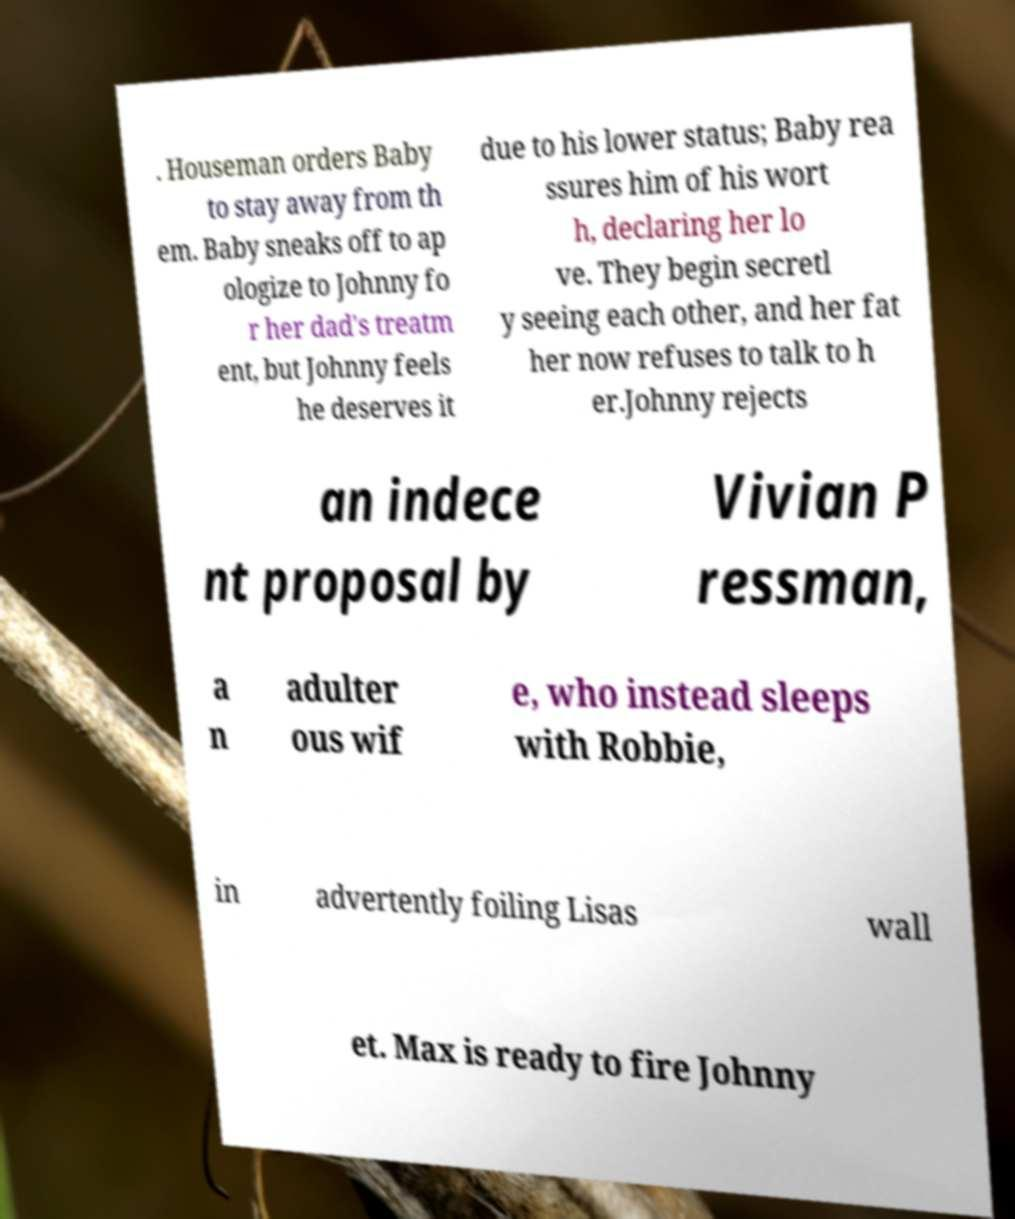I need the written content from this picture converted into text. Can you do that? . Houseman orders Baby to stay away from th em. Baby sneaks off to ap ologize to Johnny fo r her dad's treatm ent, but Johnny feels he deserves it due to his lower status; Baby rea ssures him of his wort h, declaring her lo ve. They begin secretl y seeing each other, and her fat her now refuses to talk to h er.Johnny rejects an indece nt proposal by Vivian P ressman, a n adulter ous wif e, who instead sleeps with Robbie, in advertently foiling Lisas wall et. Max is ready to fire Johnny 